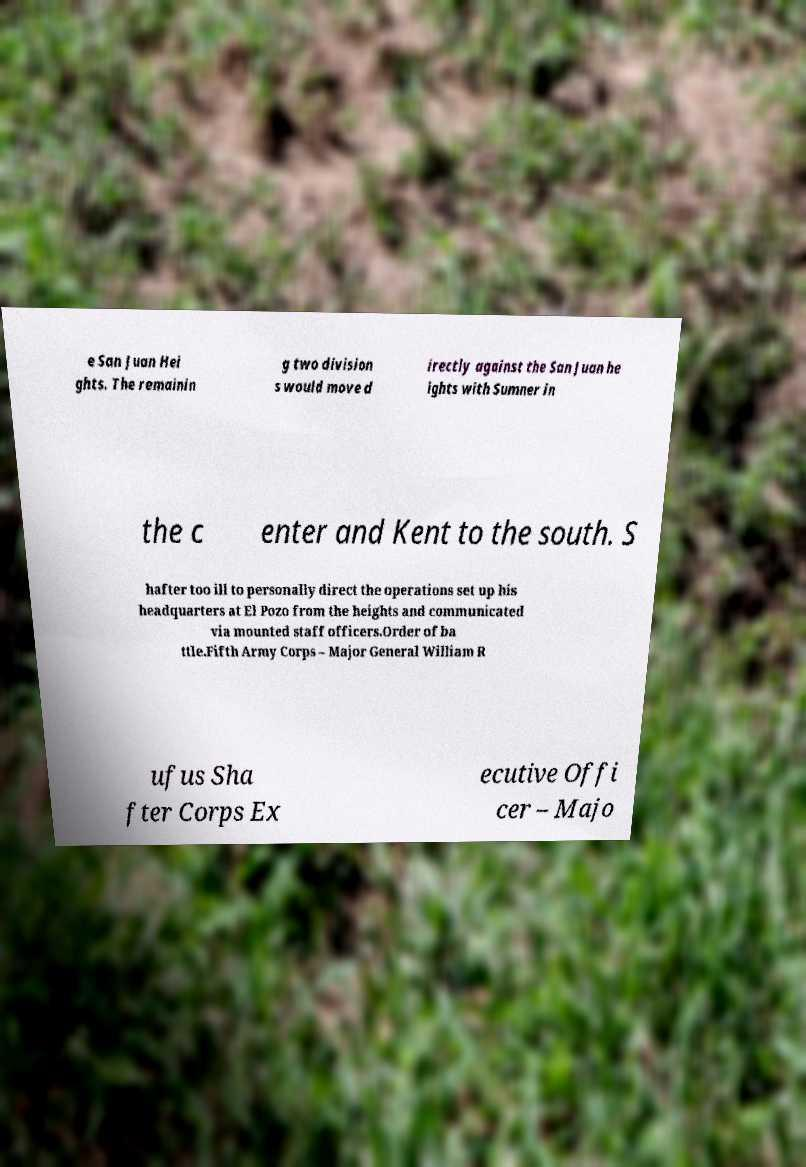What messages or text are displayed in this image? I need them in a readable, typed format. e San Juan Hei ghts. The remainin g two division s would move d irectly against the San Juan he ights with Sumner in the c enter and Kent to the south. S hafter too ill to personally direct the operations set up his headquarters at El Pozo from the heights and communicated via mounted staff officers.Order of ba ttle.Fifth Army Corps – Major General William R ufus Sha fter Corps Ex ecutive Offi cer – Majo 